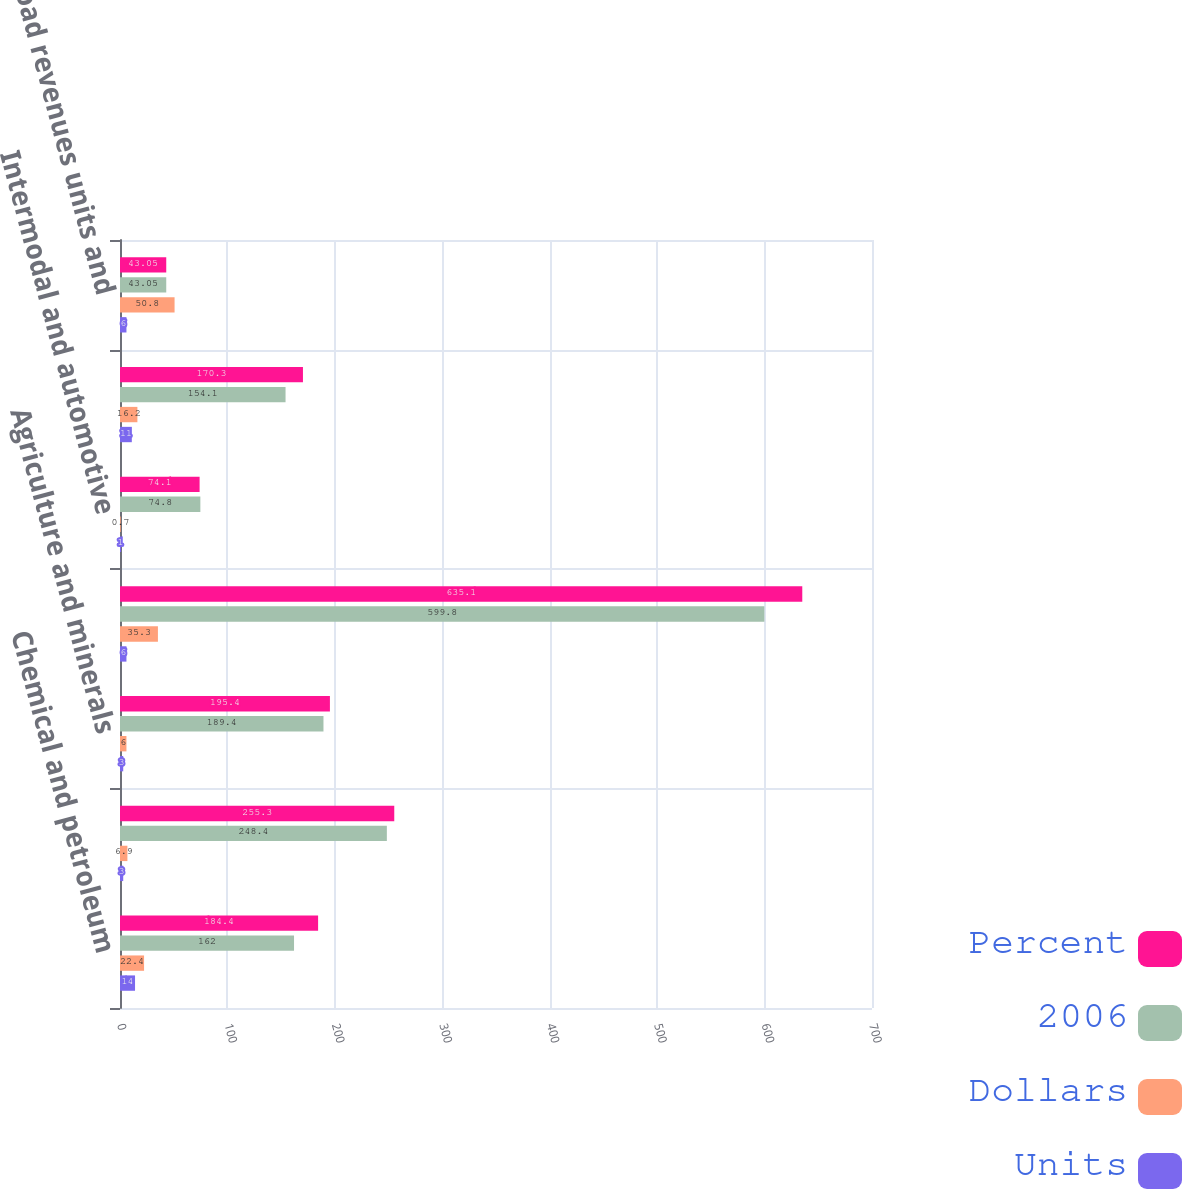Convert chart to OTSL. <chart><loc_0><loc_0><loc_500><loc_500><stacked_bar_chart><ecel><fcel>Chemical and petroleum<fcel>Forest products and metals<fcel>Agriculture and minerals<fcel>Total general commodities<fcel>Intermodal and automotive<fcel>Coal<fcel>Carload revenues units and<nl><fcel>Percent<fcel>184.4<fcel>255.3<fcel>195.4<fcel>635.1<fcel>74.1<fcel>170.3<fcel>43.05<nl><fcel>2006<fcel>162<fcel>248.4<fcel>189.4<fcel>599.8<fcel>74.8<fcel>154.1<fcel>43.05<nl><fcel>Dollars<fcel>22.4<fcel>6.9<fcel>6<fcel>35.3<fcel>0.7<fcel>16.2<fcel>50.8<nl><fcel>Units<fcel>14<fcel>3<fcel>3<fcel>6<fcel>1<fcel>11<fcel>6<nl></chart> 